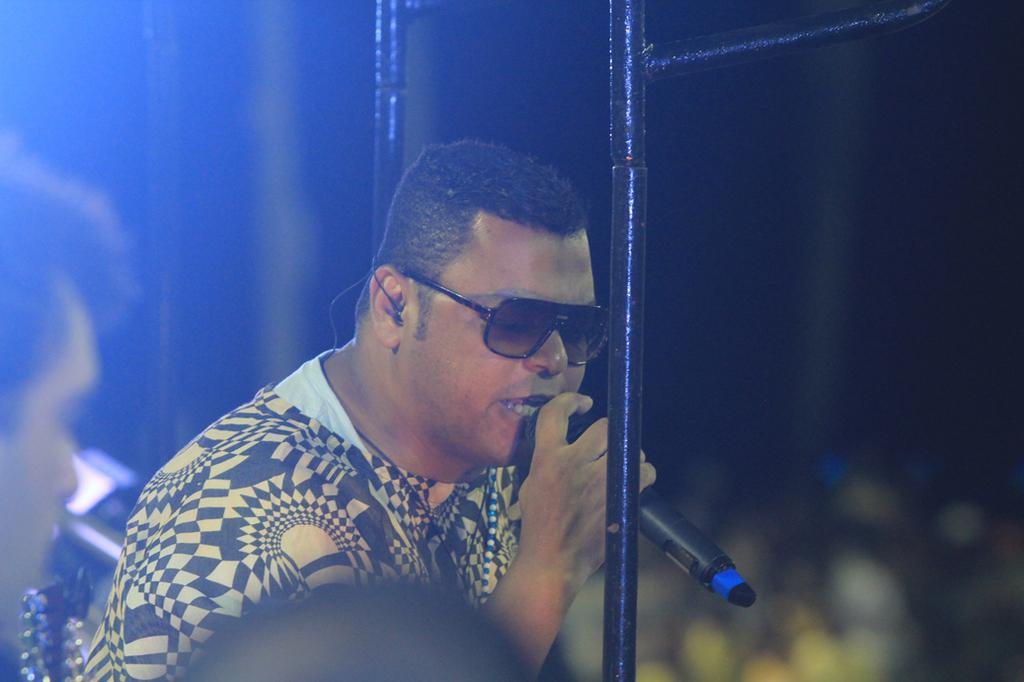What is the man in the image doing? The man appears to be singing in the image. What is the man wearing on his face? The man is wearing sunglasses in the image. What is the man holding in his right hand? The man is holding a microphone in his right hand. Is there anyone else present in the image? Yes, there is another person standing nearby. What type of detail can be seen on the dress of the man in the image? There is no dress present in the image, as the man is wearing sunglasses and holding a microphone. How many cushions are visible in the image? There are no cushions visible in the image. 